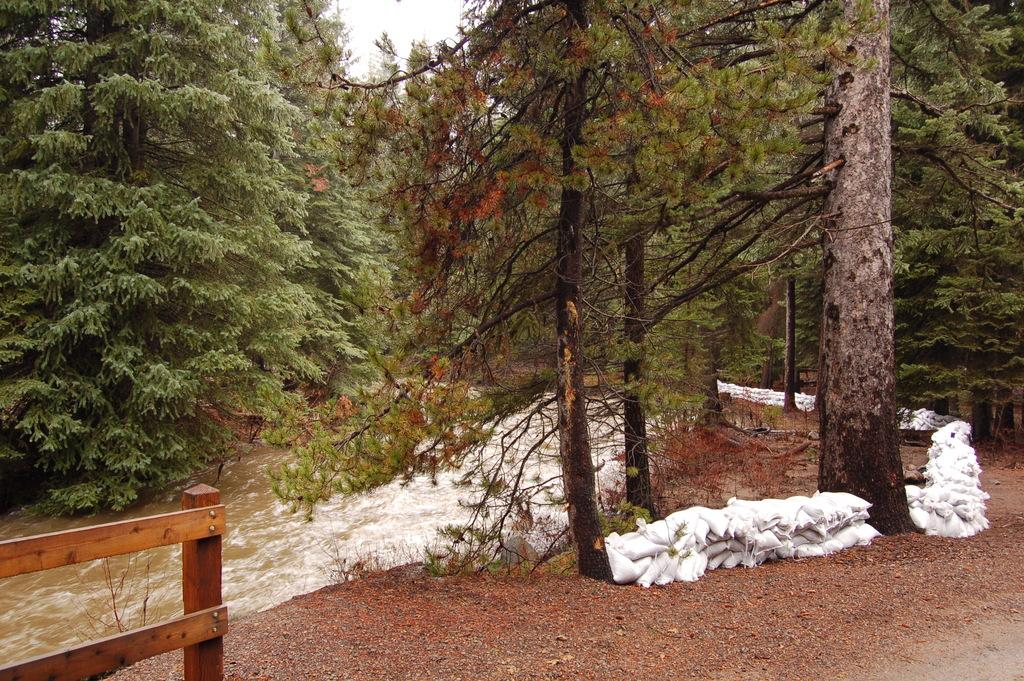What type of vegetation can be seen in the image? There are trees in the image. What is located in the middle of the image? There is water in the middle of the image. What is present at the bottom of the image? There are stones at the bottom of the image. What objects can be seen on the right side of the image? There are bags on the right side of the image. What is visible at the top of the image? The sky is visible at the top of the image. What force is causing the table to turn in the image? There is no table present in the image, so the question of a force causing it to turn is not applicable. 